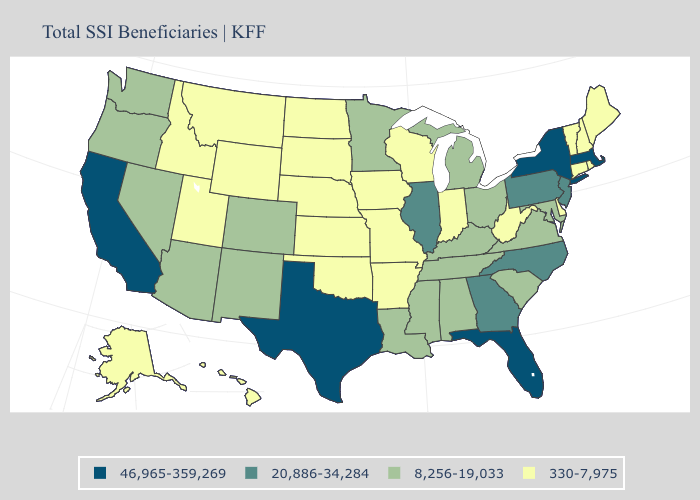Name the states that have a value in the range 8,256-19,033?
Write a very short answer. Alabama, Arizona, Colorado, Kentucky, Louisiana, Maryland, Michigan, Minnesota, Mississippi, Nevada, New Mexico, Ohio, Oregon, South Carolina, Tennessee, Virginia, Washington. What is the highest value in the USA?
Short answer required. 46,965-359,269. Does Florida have the lowest value in the USA?
Be succinct. No. What is the lowest value in states that border Vermont?
Short answer required. 330-7,975. Name the states that have a value in the range 8,256-19,033?
Answer briefly. Alabama, Arizona, Colorado, Kentucky, Louisiana, Maryland, Michigan, Minnesota, Mississippi, Nevada, New Mexico, Ohio, Oregon, South Carolina, Tennessee, Virginia, Washington. Does the first symbol in the legend represent the smallest category?
Give a very brief answer. No. Name the states that have a value in the range 330-7,975?
Answer briefly. Alaska, Arkansas, Connecticut, Delaware, Hawaii, Idaho, Indiana, Iowa, Kansas, Maine, Missouri, Montana, Nebraska, New Hampshire, North Dakota, Oklahoma, Rhode Island, South Dakota, Utah, Vermont, West Virginia, Wisconsin, Wyoming. Name the states that have a value in the range 8,256-19,033?
Quick response, please. Alabama, Arizona, Colorado, Kentucky, Louisiana, Maryland, Michigan, Minnesota, Mississippi, Nevada, New Mexico, Ohio, Oregon, South Carolina, Tennessee, Virginia, Washington. Which states have the lowest value in the West?
Answer briefly. Alaska, Hawaii, Idaho, Montana, Utah, Wyoming. Does the first symbol in the legend represent the smallest category?
Quick response, please. No. Among the states that border Idaho , which have the highest value?
Write a very short answer. Nevada, Oregon, Washington. Does Illinois have a lower value than Arizona?
Keep it brief. No. Name the states that have a value in the range 46,965-359,269?
Quick response, please. California, Florida, Massachusetts, New York, Texas. What is the lowest value in states that border Kentucky?
Concise answer only. 330-7,975. What is the value of Indiana?
Be succinct. 330-7,975. 